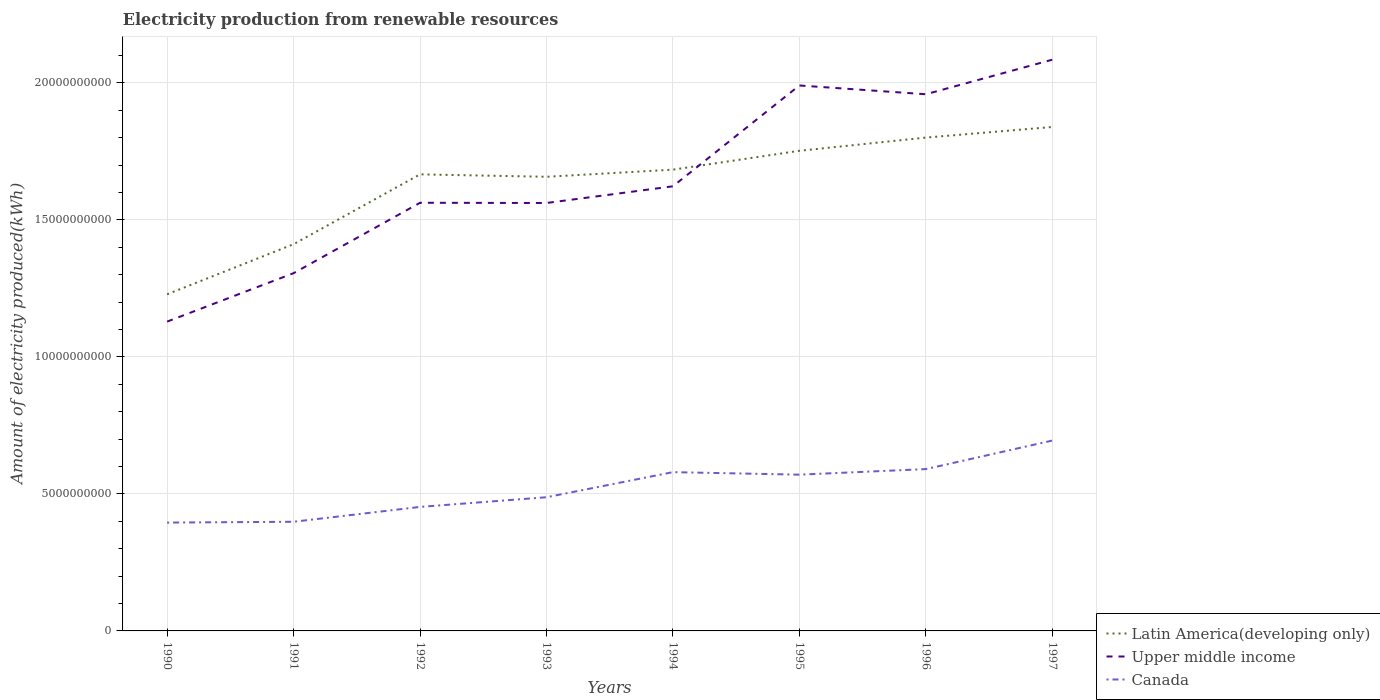How many different coloured lines are there?
Provide a succinct answer. 3. Across all years, what is the maximum amount of electricity produced in Latin America(developing only)?
Provide a succinct answer. 1.23e+1. In which year was the amount of electricity produced in Latin America(developing only) maximum?
Ensure brevity in your answer.  1990. What is the total amount of electricity produced in Latin America(developing only) in the graph?
Keep it short and to the point. -2.72e+09. What is the difference between the highest and the second highest amount of electricity produced in Canada?
Keep it short and to the point. 2.99e+09. What is the difference between the highest and the lowest amount of electricity produced in Canada?
Provide a short and direct response. 4. How many years are there in the graph?
Make the answer very short. 8. Does the graph contain any zero values?
Offer a terse response. No. Does the graph contain grids?
Offer a very short reply. Yes. Where does the legend appear in the graph?
Your response must be concise. Bottom right. How many legend labels are there?
Provide a short and direct response. 3. How are the legend labels stacked?
Your response must be concise. Vertical. What is the title of the graph?
Offer a very short reply. Electricity production from renewable resources. Does "Turkmenistan" appear as one of the legend labels in the graph?
Your answer should be very brief. No. What is the label or title of the X-axis?
Ensure brevity in your answer.  Years. What is the label or title of the Y-axis?
Your response must be concise. Amount of electricity produced(kWh). What is the Amount of electricity produced(kWh) of Latin America(developing only) in 1990?
Keep it short and to the point. 1.23e+1. What is the Amount of electricity produced(kWh) of Upper middle income in 1990?
Provide a succinct answer. 1.13e+1. What is the Amount of electricity produced(kWh) of Canada in 1990?
Provide a short and direct response. 3.95e+09. What is the Amount of electricity produced(kWh) of Latin America(developing only) in 1991?
Your response must be concise. 1.41e+1. What is the Amount of electricity produced(kWh) in Upper middle income in 1991?
Keep it short and to the point. 1.31e+1. What is the Amount of electricity produced(kWh) of Canada in 1991?
Offer a terse response. 3.98e+09. What is the Amount of electricity produced(kWh) of Latin America(developing only) in 1992?
Provide a short and direct response. 1.67e+1. What is the Amount of electricity produced(kWh) of Upper middle income in 1992?
Your answer should be compact. 1.56e+1. What is the Amount of electricity produced(kWh) in Canada in 1992?
Keep it short and to the point. 4.53e+09. What is the Amount of electricity produced(kWh) of Latin America(developing only) in 1993?
Make the answer very short. 1.66e+1. What is the Amount of electricity produced(kWh) of Upper middle income in 1993?
Give a very brief answer. 1.56e+1. What is the Amount of electricity produced(kWh) in Canada in 1993?
Provide a succinct answer. 4.88e+09. What is the Amount of electricity produced(kWh) in Latin America(developing only) in 1994?
Your answer should be compact. 1.68e+1. What is the Amount of electricity produced(kWh) in Upper middle income in 1994?
Your response must be concise. 1.62e+1. What is the Amount of electricity produced(kWh) of Canada in 1994?
Offer a very short reply. 5.80e+09. What is the Amount of electricity produced(kWh) in Latin America(developing only) in 1995?
Your response must be concise. 1.75e+1. What is the Amount of electricity produced(kWh) in Upper middle income in 1995?
Provide a short and direct response. 1.99e+1. What is the Amount of electricity produced(kWh) of Canada in 1995?
Provide a short and direct response. 5.70e+09. What is the Amount of electricity produced(kWh) of Latin America(developing only) in 1996?
Your answer should be very brief. 1.80e+1. What is the Amount of electricity produced(kWh) of Upper middle income in 1996?
Your response must be concise. 1.96e+1. What is the Amount of electricity produced(kWh) of Canada in 1996?
Your answer should be very brief. 5.91e+09. What is the Amount of electricity produced(kWh) of Latin America(developing only) in 1997?
Offer a terse response. 1.84e+1. What is the Amount of electricity produced(kWh) in Upper middle income in 1997?
Ensure brevity in your answer.  2.08e+1. What is the Amount of electricity produced(kWh) of Canada in 1997?
Offer a very short reply. 6.95e+09. Across all years, what is the maximum Amount of electricity produced(kWh) of Latin America(developing only)?
Make the answer very short. 1.84e+1. Across all years, what is the maximum Amount of electricity produced(kWh) of Upper middle income?
Your answer should be very brief. 2.08e+1. Across all years, what is the maximum Amount of electricity produced(kWh) in Canada?
Offer a terse response. 6.95e+09. Across all years, what is the minimum Amount of electricity produced(kWh) of Latin America(developing only)?
Keep it short and to the point. 1.23e+1. Across all years, what is the minimum Amount of electricity produced(kWh) in Upper middle income?
Offer a very short reply. 1.13e+1. Across all years, what is the minimum Amount of electricity produced(kWh) of Canada?
Keep it short and to the point. 3.95e+09. What is the total Amount of electricity produced(kWh) in Latin America(developing only) in the graph?
Keep it short and to the point. 1.30e+11. What is the total Amount of electricity produced(kWh) in Upper middle income in the graph?
Offer a terse response. 1.32e+11. What is the total Amount of electricity produced(kWh) of Canada in the graph?
Your answer should be compact. 4.17e+1. What is the difference between the Amount of electricity produced(kWh) in Latin America(developing only) in 1990 and that in 1991?
Ensure brevity in your answer.  -1.83e+09. What is the difference between the Amount of electricity produced(kWh) of Upper middle income in 1990 and that in 1991?
Make the answer very short. -1.77e+09. What is the difference between the Amount of electricity produced(kWh) of Canada in 1990 and that in 1991?
Offer a terse response. -3.00e+07. What is the difference between the Amount of electricity produced(kWh) in Latin America(developing only) in 1990 and that in 1992?
Keep it short and to the point. -4.38e+09. What is the difference between the Amount of electricity produced(kWh) of Upper middle income in 1990 and that in 1992?
Keep it short and to the point. -4.34e+09. What is the difference between the Amount of electricity produced(kWh) of Canada in 1990 and that in 1992?
Give a very brief answer. -5.72e+08. What is the difference between the Amount of electricity produced(kWh) in Latin America(developing only) in 1990 and that in 1993?
Ensure brevity in your answer.  -4.29e+09. What is the difference between the Amount of electricity produced(kWh) of Upper middle income in 1990 and that in 1993?
Provide a short and direct response. -4.33e+09. What is the difference between the Amount of electricity produced(kWh) of Canada in 1990 and that in 1993?
Provide a succinct answer. -9.25e+08. What is the difference between the Amount of electricity produced(kWh) of Latin America(developing only) in 1990 and that in 1994?
Offer a very short reply. -4.55e+09. What is the difference between the Amount of electricity produced(kWh) of Upper middle income in 1990 and that in 1994?
Offer a very short reply. -4.94e+09. What is the difference between the Amount of electricity produced(kWh) of Canada in 1990 and that in 1994?
Provide a succinct answer. -1.84e+09. What is the difference between the Amount of electricity produced(kWh) in Latin America(developing only) in 1990 and that in 1995?
Your response must be concise. -5.24e+09. What is the difference between the Amount of electricity produced(kWh) in Upper middle income in 1990 and that in 1995?
Make the answer very short. -8.62e+09. What is the difference between the Amount of electricity produced(kWh) of Canada in 1990 and that in 1995?
Provide a succinct answer. -1.75e+09. What is the difference between the Amount of electricity produced(kWh) of Latin America(developing only) in 1990 and that in 1996?
Provide a short and direct response. -5.72e+09. What is the difference between the Amount of electricity produced(kWh) in Upper middle income in 1990 and that in 1996?
Your answer should be very brief. -8.30e+09. What is the difference between the Amount of electricity produced(kWh) of Canada in 1990 and that in 1996?
Offer a terse response. -1.95e+09. What is the difference between the Amount of electricity produced(kWh) in Latin America(developing only) in 1990 and that in 1997?
Make the answer very short. -6.11e+09. What is the difference between the Amount of electricity produced(kWh) in Upper middle income in 1990 and that in 1997?
Provide a short and direct response. -9.56e+09. What is the difference between the Amount of electricity produced(kWh) of Canada in 1990 and that in 1997?
Keep it short and to the point. -2.99e+09. What is the difference between the Amount of electricity produced(kWh) in Latin America(developing only) in 1991 and that in 1992?
Provide a short and direct response. -2.55e+09. What is the difference between the Amount of electricity produced(kWh) of Upper middle income in 1991 and that in 1992?
Provide a short and direct response. -2.57e+09. What is the difference between the Amount of electricity produced(kWh) of Canada in 1991 and that in 1992?
Keep it short and to the point. -5.42e+08. What is the difference between the Amount of electricity produced(kWh) of Latin America(developing only) in 1991 and that in 1993?
Provide a short and direct response. -2.46e+09. What is the difference between the Amount of electricity produced(kWh) in Upper middle income in 1991 and that in 1993?
Give a very brief answer. -2.56e+09. What is the difference between the Amount of electricity produced(kWh) in Canada in 1991 and that in 1993?
Your answer should be very brief. -8.95e+08. What is the difference between the Amount of electricity produced(kWh) in Latin America(developing only) in 1991 and that in 1994?
Provide a short and direct response. -2.72e+09. What is the difference between the Amount of electricity produced(kWh) in Upper middle income in 1991 and that in 1994?
Keep it short and to the point. -3.17e+09. What is the difference between the Amount of electricity produced(kWh) of Canada in 1991 and that in 1994?
Ensure brevity in your answer.  -1.81e+09. What is the difference between the Amount of electricity produced(kWh) in Latin America(developing only) in 1991 and that in 1995?
Offer a very short reply. -3.41e+09. What is the difference between the Amount of electricity produced(kWh) in Upper middle income in 1991 and that in 1995?
Offer a very short reply. -6.85e+09. What is the difference between the Amount of electricity produced(kWh) in Canada in 1991 and that in 1995?
Ensure brevity in your answer.  -1.72e+09. What is the difference between the Amount of electricity produced(kWh) in Latin America(developing only) in 1991 and that in 1996?
Your answer should be compact. -3.89e+09. What is the difference between the Amount of electricity produced(kWh) of Upper middle income in 1991 and that in 1996?
Your answer should be very brief. -6.53e+09. What is the difference between the Amount of electricity produced(kWh) of Canada in 1991 and that in 1996?
Keep it short and to the point. -1.92e+09. What is the difference between the Amount of electricity produced(kWh) in Latin America(developing only) in 1991 and that in 1997?
Your response must be concise. -4.28e+09. What is the difference between the Amount of electricity produced(kWh) in Upper middle income in 1991 and that in 1997?
Your answer should be compact. -7.79e+09. What is the difference between the Amount of electricity produced(kWh) of Canada in 1991 and that in 1997?
Your response must be concise. -2.96e+09. What is the difference between the Amount of electricity produced(kWh) in Latin America(developing only) in 1992 and that in 1993?
Your response must be concise. 8.90e+07. What is the difference between the Amount of electricity produced(kWh) in Upper middle income in 1992 and that in 1993?
Your answer should be very brief. 8.00e+06. What is the difference between the Amount of electricity produced(kWh) in Canada in 1992 and that in 1993?
Your answer should be compact. -3.53e+08. What is the difference between the Amount of electricity produced(kWh) in Latin America(developing only) in 1992 and that in 1994?
Your answer should be compact. -1.72e+08. What is the difference between the Amount of electricity produced(kWh) in Upper middle income in 1992 and that in 1994?
Your answer should be very brief. -6.01e+08. What is the difference between the Amount of electricity produced(kWh) in Canada in 1992 and that in 1994?
Make the answer very short. -1.27e+09. What is the difference between the Amount of electricity produced(kWh) in Latin America(developing only) in 1992 and that in 1995?
Your response must be concise. -8.60e+08. What is the difference between the Amount of electricity produced(kWh) of Upper middle income in 1992 and that in 1995?
Give a very brief answer. -4.28e+09. What is the difference between the Amount of electricity produced(kWh) of Canada in 1992 and that in 1995?
Keep it short and to the point. -1.18e+09. What is the difference between the Amount of electricity produced(kWh) of Latin America(developing only) in 1992 and that in 1996?
Provide a short and direct response. -1.34e+09. What is the difference between the Amount of electricity produced(kWh) of Upper middle income in 1992 and that in 1996?
Give a very brief answer. -3.96e+09. What is the difference between the Amount of electricity produced(kWh) in Canada in 1992 and that in 1996?
Give a very brief answer. -1.38e+09. What is the difference between the Amount of electricity produced(kWh) in Latin America(developing only) in 1992 and that in 1997?
Offer a terse response. -1.73e+09. What is the difference between the Amount of electricity produced(kWh) in Upper middle income in 1992 and that in 1997?
Make the answer very short. -5.22e+09. What is the difference between the Amount of electricity produced(kWh) in Canada in 1992 and that in 1997?
Your response must be concise. -2.42e+09. What is the difference between the Amount of electricity produced(kWh) in Latin America(developing only) in 1993 and that in 1994?
Give a very brief answer. -2.61e+08. What is the difference between the Amount of electricity produced(kWh) in Upper middle income in 1993 and that in 1994?
Your answer should be compact. -6.09e+08. What is the difference between the Amount of electricity produced(kWh) of Canada in 1993 and that in 1994?
Offer a very short reply. -9.16e+08. What is the difference between the Amount of electricity produced(kWh) of Latin America(developing only) in 1993 and that in 1995?
Your response must be concise. -9.49e+08. What is the difference between the Amount of electricity produced(kWh) in Upper middle income in 1993 and that in 1995?
Give a very brief answer. -4.29e+09. What is the difference between the Amount of electricity produced(kWh) of Canada in 1993 and that in 1995?
Offer a terse response. -8.24e+08. What is the difference between the Amount of electricity produced(kWh) of Latin America(developing only) in 1993 and that in 1996?
Keep it short and to the point. -1.43e+09. What is the difference between the Amount of electricity produced(kWh) in Upper middle income in 1993 and that in 1996?
Offer a terse response. -3.97e+09. What is the difference between the Amount of electricity produced(kWh) in Canada in 1993 and that in 1996?
Offer a very short reply. -1.03e+09. What is the difference between the Amount of electricity produced(kWh) in Latin America(developing only) in 1993 and that in 1997?
Offer a terse response. -1.82e+09. What is the difference between the Amount of electricity produced(kWh) of Upper middle income in 1993 and that in 1997?
Your response must be concise. -5.23e+09. What is the difference between the Amount of electricity produced(kWh) of Canada in 1993 and that in 1997?
Your response must be concise. -2.07e+09. What is the difference between the Amount of electricity produced(kWh) in Latin America(developing only) in 1994 and that in 1995?
Provide a short and direct response. -6.88e+08. What is the difference between the Amount of electricity produced(kWh) in Upper middle income in 1994 and that in 1995?
Your response must be concise. -3.68e+09. What is the difference between the Amount of electricity produced(kWh) of Canada in 1994 and that in 1995?
Keep it short and to the point. 9.20e+07. What is the difference between the Amount of electricity produced(kWh) of Latin America(developing only) in 1994 and that in 1996?
Ensure brevity in your answer.  -1.17e+09. What is the difference between the Amount of electricity produced(kWh) of Upper middle income in 1994 and that in 1996?
Keep it short and to the point. -3.36e+09. What is the difference between the Amount of electricity produced(kWh) in Canada in 1994 and that in 1996?
Keep it short and to the point. -1.11e+08. What is the difference between the Amount of electricity produced(kWh) of Latin America(developing only) in 1994 and that in 1997?
Give a very brief answer. -1.56e+09. What is the difference between the Amount of electricity produced(kWh) of Upper middle income in 1994 and that in 1997?
Provide a short and direct response. -4.62e+09. What is the difference between the Amount of electricity produced(kWh) of Canada in 1994 and that in 1997?
Your answer should be compact. -1.15e+09. What is the difference between the Amount of electricity produced(kWh) of Latin America(developing only) in 1995 and that in 1996?
Ensure brevity in your answer.  -4.82e+08. What is the difference between the Amount of electricity produced(kWh) in Upper middle income in 1995 and that in 1996?
Make the answer very short. 3.20e+08. What is the difference between the Amount of electricity produced(kWh) in Canada in 1995 and that in 1996?
Keep it short and to the point. -2.03e+08. What is the difference between the Amount of electricity produced(kWh) in Latin America(developing only) in 1995 and that in 1997?
Keep it short and to the point. -8.69e+08. What is the difference between the Amount of electricity produced(kWh) of Upper middle income in 1995 and that in 1997?
Offer a terse response. -9.40e+08. What is the difference between the Amount of electricity produced(kWh) in Canada in 1995 and that in 1997?
Your response must be concise. -1.24e+09. What is the difference between the Amount of electricity produced(kWh) in Latin America(developing only) in 1996 and that in 1997?
Keep it short and to the point. -3.87e+08. What is the difference between the Amount of electricity produced(kWh) in Upper middle income in 1996 and that in 1997?
Offer a very short reply. -1.26e+09. What is the difference between the Amount of electricity produced(kWh) of Canada in 1996 and that in 1997?
Make the answer very short. -1.04e+09. What is the difference between the Amount of electricity produced(kWh) of Latin America(developing only) in 1990 and the Amount of electricity produced(kWh) of Upper middle income in 1991?
Your response must be concise. -7.70e+08. What is the difference between the Amount of electricity produced(kWh) in Latin America(developing only) in 1990 and the Amount of electricity produced(kWh) in Canada in 1991?
Keep it short and to the point. 8.30e+09. What is the difference between the Amount of electricity produced(kWh) in Upper middle income in 1990 and the Amount of electricity produced(kWh) in Canada in 1991?
Make the answer very short. 7.30e+09. What is the difference between the Amount of electricity produced(kWh) of Latin America(developing only) in 1990 and the Amount of electricity produced(kWh) of Upper middle income in 1992?
Provide a short and direct response. -3.34e+09. What is the difference between the Amount of electricity produced(kWh) of Latin America(developing only) in 1990 and the Amount of electricity produced(kWh) of Canada in 1992?
Make the answer very short. 7.76e+09. What is the difference between the Amount of electricity produced(kWh) in Upper middle income in 1990 and the Amount of electricity produced(kWh) in Canada in 1992?
Your answer should be compact. 6.76e+09. What is the difference between the Amount of electricity produced(kWh) in Latin America(developing only) in 1990 and the Amount of electricity produced(kWh) in Upper middle income in 1993?
Provide a succinct answer. -3.33e+09. What is the difference between the Amount of electricity produced(kWh) in Latin America(developing only) in 1990 and the Amount of electricity produced(kWh) in Canada in 1993?
Give a very brief answer. 7.41e+09. What is the difference between the Amount of electricity produced(kWh) in Upper middle income in 1990 and the Amount of electricity produced(kWh) in Canada in 1993?
Keep it short and to the point. 6.41e+09. What is the difference between the Amount of electricity produced(kWh) in Latin America(developing only) in 1990 and the Amount of electricity produced(kWh) in Upper middle income in 1994?
Your answer should be compact. -3.94e+09. What is the difference between the Amount of electricity produced(kWh) in Latin America(developing only) in 1990 and the Amount of electricity produced(kWh) in Canada in 1994?
Make the answer very short. 6.49e+09. What is the difference between the Amount of electricity produced(kWh) in Upper middle income in 1990 and the Amount of electricity produced(kWh) in Canada in 1994?
Your answer should be compact. 5.49e+09. What is the difference between the Amount of electricity produced(kWh) in Latin America(developing only) in 1990 and the Amount of electricity produced(kWh) in Upper middle income in 1995?
Offer a very short reply. -7.62e+09. What is the difference between the Amount of electricity produced(kWh) in Latin America(developing only) in 1990 and the Amount of electricity produced(kWh) in Canada in 1995?
Your response must be concise. 6.58e+09. What is the difference between the Amount of electricity produced(kWh) of Upper middle income in 1990 and the Amount of electricity produced(kWh) of Canada in 1995?
Ensure brevity in your answer.  5.59e+09. What is the difference between the Amount of electricity produced(kWh) of Latin America(developing only) in 1990 and the Amount of electricity produced(kWh) of Upper middle income in 1996?
Your answer should be very brief. -7.30e+09. What is the difference between the Amount of electricity produced(kWh) of Latin America(developing only) in 1990 and the Amount of electricity produced(kWh) of Canada in 1996?
Your answer should be compact. 6.38e+09. What is the difference between the Amount of electricity produced(kWh) in Upper middle income in 1990 and the Amount of electricity produced(kWh) in Canada in 1996?
Give a very brief answer. 5.38e+09. What is the difference between the Amount of electricity produced(kWh) in Latin America(developing only) in 1990 and the Amount of electricity produced(kWh) in Upper middle income in 1997?
Keep it short and to the point. -8.56e+09. What is the difference between the Amount of electricity produced(kWh) of Latin America(developing only) in 1990 and the Amount of electricity produced(kWh) of Canada in 1997?
Make the answer very short. 5.34e+09. What is the difference between the Amount of electricity produced(kWh) of Upper middle income in 1990 and the Amount of electricity produced(kWh) of Canada in 1997?
Your response must be concise. 4.34e+09. What is the difference between the Amount of electricity produced(kWh) in Latin America(developing only) in 1991 and the Amount of electricity produced(kWh) in Upper middle income in 1992?
Offer a terse response. -1.51e+09. What is the difference between the Amount of electricity produced(kWh) of Latin America(developing only) in 1991 and the Amount of electricity produced(kWh) of Canada in 1992?
Provide a succinct answer. 9.59e+09. What is the difference between the Amount of electricity produced(kWh) in Upper middle income in 1991 and the Amount of electricity produced(kWh) in Canada in 1992?
Your answer should be compact. 8.53e+09. What is the difference between the Amount of electricity produced(kWh) of Latin America(developing only) in 1991 and the Amount of electricity produced(kWh) of Upper middle income in 1993?
Your answer should be compact. -1.50e+09. What is the difference between the Amount of electricity produced(kWh) in Latin America(developing only) in 1991 and the Amount of electricity produced(kWh) in Canada in 1993?
Keep it short and to the point. 9.24e+09. What is the difference between the Amount of electricity produced(kWh) of Upper middle income in 1991 and the Amount of electricity produced(kWh) of Canada in 1993?
Provide a short and direct response. 8.18e+09. What is the difference between the Amount of electricity produced(kWh) in Latin America(developing only) in 1991 and the Amount of electricity produced(kWh) in Upper middle income in 1994?
Keep it short and to the point. -2.11e+09. What is the difference between the Amount of electricity produced(kWh) in Latin America(developing only) in 1991 and the Amount of electricity produced(kWh) in Canada in 1994?
Ensure brevity in your answer.  8.32e+09. What is the difference between the Amount of electricity produced(kWh) of Upper middle income in 1991 and the Amount of electricity produced(kWh) of Canada in 1994?
Your answer should be compact. 7.26e+09. What is the difference between the Amount of electricity produced(kWh) in Latin America(developing only) in 1991 and the Amount of electricity produced(kWh) in Upper middle income in 1995?
Make the answer very short. -5.79e+09. What is the difference between the Amount of electricity produced(kWh) in Latin America(developing only) in 1991 and the Amount of electricity produced(kWh) in Canada in 1995?
Give a very brief answer. 8.41e+09. What is the difference between the Amount of electricity produced(kWh) of Upper middle income in 1991 and the Amount of electricity produced(kWh) of Canada in 1995?
Your response must be concise. 7.35e+09. What is the difference between the Amount of electricity produced(kWh) of Latin America(developing only) in 1991 and the Amount of electricity produced(kWh) of Upper middle income in 1996?
Ensure brevity in your answer.  -5.47e+09. What is the difference between the Amount of electricity produced(kWh) in Latin America(developing only) in 1991 and the Amount of electricity produced(kWh) in Canada in 1996?
Offer a very short reply. 8.21e+09. What is the difference between the Amount of electricity produced(kWh) of Upper middle income in 1991 and the Amount of electricity produced(kWh) of Canada in 1996?
Give a very brief answer. 7.15e+09. What is the difference between the Amount of electricity produced(kWh) in Latin America(developing only) in 1991 and the Amount of electricity produced(kWh) in Upper middle income in 1997?
Your response must be concise. -6.73e+09. What is the difference between the Amount of electricity produced(kWh) of Latin America(developing only) in 1991 and the Amount of electricity produced(kWh) of Canada in 1997?
Your response must be concise. 7.17e+09. What is the difference between the Amount of electricity produced(kWh) of Upper middle income in 1991 and the Amount of electricity produced(kWh) of Canada in 1997?
Provide a succinct answer. 6.11e+09. What is the difference between the Amount of electricity produced(kWh) of Latin America(developing only) in 1992 and the Amount of electricity produced(kWh) of Upper middle income in 1993?
Your answer should be very brief. 1.04e+09. What is the difference between the Amount of electricity produced(kWh) of Latin America(developing only) in 1992 and the Amount of electricity produced(kWh) of Canada in 1993?
Your response must be concise. 1.18e+1. What is the difference between the Amount of electricity produced(kWh) of Upper middle income in 1992 and the Amount of electricity produced(kWh) of Canada in 1993?
Ensure brevity in your answer.  1.07e+1. What is the difference between the Amount of electricity produced(kWh) of Latin America(developing only) in 1992 and the Amount of electricity produced(kWh) of Upper middle income in 1994?
Your answer should be compact. 4.36e+08. What is the difference between the Amount of electricity produced(kWh) of Latin America(developing only) in 1992 and the Amount of electricity produced(kWh) of Canada in 1994?
Offer a very short reply. 1.09e+1. What is the difference between the Amount of electricity produced(kWh) of Upper middle income in 1992 and the Amount of electricity produced(kWh) of Canada in 1994?
Offer a terse response. 9.83e+09. What is the difference between the Amount of electricity produced(kWh) in Latin America(developing only) in 1992 and the Amount of electricity produced(kWh) in Upper middle income in 1995?
Offer a terse response. -3.24e+09. What is the difference between the Amount of electricity produced(kWh) of Latin America(developing only) in 1992 and the Amount of electricity produced(kWh) of Canada in 1995?
Provide a succinct answer. 1.10e+1. What is the difference between the Amount of electricity produced(kWh) in Upper middle income in 1992 and the Amount of electricity produced(kWh) in Canada in 1995?
Keep it short and to the point. 9.92e+09. What is the difference between the Amount of electricity produced(kWh) of Latin America(developing only) in 1992 and the Amount of electricity produced(kWh) of Upper middle income in 1996?
Offer a very short reply. -2.92e+09. What is the difference between the Amount of electricity produced(kWh) in Latin America(developing only) in 1992 and the Amount of electricity produced(kWh) in Canada in 1996?
Make the answer very short. 1.08e+1. What is the difference between the Amount of electricity produced(kWh) of Upper middle income in 1992 and the Amount of electricity produced(kWh) of Canada in 1996?
Offer a very short reply. 9.72e+09. What is the difference between the Amount of electricity produced(kWh) of Latin America(developing only) in 1992 and the Amount of electricity produced(kWh) of Upper middle income in 1997?
Make the answer very short. -4.18e+09. What is the difference between the Amount of electricity produced(kWh) of Latin America(developing only) in 1992 and the Amount of electricity produced(kWh) of Canada in 1997?
Your answer should be very brief. 9.72e+09. What is the difference between the Amount of electricity produced(kWh) of Upper middle income in 1992 and the Amount of electricity produced(kWh) of Canada in 1997?
Your response must be concise. 8.68e+09. What is the difference between the Amount of electricity produced(kWh) in Latin America(developing only) in 1993 and the Amount of electricity produced(kWh) in Upper middle income in 1994?
Make the answer very short. 3.47e+08. What is the difference between the Amount of electricity produced(kWh) in Latin America(developing only) in 1993 and the Amount of electricity produced(kWh) in Canada in 1994?
Your answer should be compact. 1.08e+1. What is the difference between the Amount of electricity produced(kWh) in Upper middle income in 1993 and the Amount of electricity produced(kWh) in Canada in 1994?
Make the answer very short. 9.82e+09. What is the difference between the Amount of electricity produced(kWh) of Latin America(developing only) in 1993 and the Amount of electricity produced(kWh) of Upper middle income in 1995?
Your response must be concise. -3.33e+09. What is the difference between the Amount of electricity produced(kWh) of Latin America(developing only) in 1993 and the Amount of electricity produced(kWh) of Canada in 1995?
Keep it short and to the point. 1.09e+1. What is the difference between the Amount of electricity produced(kWh) of Upper middle income in 1993 and the Amount of electricity produced(kWh) of Canada in 1995?
Offer a very short reply. 9.92e+09. What is the difference between the Amount of electricity produced(kWh) in Latin America(developing only) in 1993 and the Amount of electricity produced(kWh) in Upper middle income in 1996?
Offer a very short reply. -3.01e+09. What is the difference between the Amount of electricity produced(kWh) of Latin America(developing only) in 1993 and the Amount of electricity produced(kWh) of Canada in 1996?
Give a very brief answer. 1.07e+1. What is the difference between the Amount of electricity produced(kWh) in Upper middle income in 1993 and the Amount of electricity produced(kWh) in Canada in 1996?
Offer a terse response. 9.71e+09. What is the difference between the Amount of electricity produced(kWh) of Latin America(developing only) in 1993 and the Amount of electricity produced(kWh) of Upper middle income in 1997?
Keep it short and to the point. -4.27e+09. What is the difference between the Amount of electricity produced(kWh) in Latin America(developing only) in 1993 and the Amount of electricity produced(kWh) in Canada in 1997?
Provide a succinct answer. 9.63e+09. What is the difference between the Amount of electricity produced(kWh) in Upper middle income in 1993 and the Amount of electricity produced(kWh) in Canada in 1997?
Your response must be concise. 8.67e+09. What is the difference between the Amount of electricity produced(kWh) of Latin America(developing only) in 1994 and the Amount of electricity produced(kWh) of Upper middle income in 1995?
Offer a terse response. -3.07e+09. What is the difference between the Amount of electricity produced(kWh) of Latin America(developing only) in 1994 and the Amount of electricity produced(kWh) of Canada in 1995?
Provide a succinct answer. 1.11e+1. What is the difference between the Amount of electricity produced(kWh) of Upper middle income in 1994 and the Amount of electricity produced(kWh) of Canada in 1995?
Give a very brief answer. 1.05e+1. What is the difference between the Amount of electricity produced(kWh) of Latin America(developing only) in 1994 and the Amount of electricity produced(kWh) of Upper middle income in 1996?
Give a very brief answer. -2.75e+09. What is the difference between the Amount of electricity produced(kWh) of Latin America(developing only) in 1994 and the Amount of electricity produced(kWh) of Canada in 1996?
Provide a succinct answer. 1.09e+1. What is the difference between the Amount of electricity produced(kWh) of Upper middle income in 1994 and the Amount of electricity produced(kWh) of Canada in 1996?
Offer a very short reply. 1.03e+1. What is the difference between the Amount of electricity produced(kWh) of Latin America(developing only) in 1994 and the Amount of electricity produced(kWh) of Upper middle income in 1997?
Make the answer very short. -4.01e+09. What is the difference between the Amount of electricity produced(kWh) of Latin America(developing only) in 1994 and the Amount of electricity produced(kWh) of Canada in 1997?
Provide a short and direct response. 9.89e+09. What is the difference between the Amount of electricity produced(kWh) in Upper middle income in 1994 and the Amount of electricity produced(kWh) in Canada in 1997?
Ensure brevity in your answer.  9.28e+09. What is the difference between the Amount of electricity produced(kWh) of Latin America(developing only) in 1995 and the Amount of electricity produced(kWh) of Upper middle income in 1996?
Keep it short and to the point. -2.06e+09. What is the difference between the Amount of electricity produced(kWh) of Latin America(developing only) in 1995 and the Amount of electricity produced(kWh) of Canada in 1996?
Make the answer very short. 1.16e+1. What is the difference between the Amount of electricity produced(kWh) of Upper middle income in 1995 and the Amount of electricity produced(kWh) of Canada in 1996?
Your answer should be very brief. 1.40e+1. What is the difference between the Amount of electricity produced(kWh) in Latin America(developing only) in 1995 and the Amount of electricity produced(kWh) in Upper middle income in 1997?
Give a very brief answer. -3.32e+09. What is the difference between the Amount of electricity produced(kWh) in Latin America(developing only) in 1995 and the Amount of electricity produced(kWh) in Canada in 1997?
Your response must be concise. 1.06e+1. What is the difference between the Amount of electricity produced(kWh) of Upper middle income in 1995 and the Amount of electricity produced(kWh) of Canada in 1997?
Your answer should be compact. 1.30e+1. What is the difference between the Amount of electricity produced(kWh) of Latin America(developing only) in 1996 and the Amount of electricity produced(kWh) of Upper middle income in 1997?
Provide a succinct answer. -2.84e+09. What is the difference between the Amount of electricity produced(kWh) of Latin America(developing only) in 1996 and the Amount of electricity produced(kWh) of Canada in 1997?
Keep it short and to the point. 1.11e+1. What is the difference between the Amount of electricity produced(kWh) of Upper middle income in 1996 and the Amount of electricity produced(kWh) of Canada in 1997?
Your answer should be very brief. 1.26e+1. What is the average Amount of electricity produced(kWh) of Latin America(developing only) per year?
Give a very brief answer. 1.63e+1. What is the average Amount of electricity produced(kWh) of Upper middle income per year?
Your answer should be very brief. 1.65e+1. What is the average Amount of electricity produced(kWh) in Canada per year?
Provide a short and direct response. 5.21e+09. In the year 1990, what is the difference between the Amount of electricity produced(kWh) of Latin America(developing only) and Amount of electricity produced(kWh) of Upper middle income?
Your answer should be compact. 9.97e+08. In the year 1990, what is the difference between the Amount of electricity produced(kWh) of Latin America(developing only) and Amount of electricity produced(kWh) of Canada?
Offer a terse response. 8.33e+09. In the year 1990, what is the difference between the Amount of electricity produced(kWh) of Upper middle income and Amount of electricity produced(kWh) of Canada?
Ensure brevity in your answer.  7.34e+09. In the year 1991, what is the difference between the Amount of electricity produced(kWh) of Latin America(developing only) and Amount of electricity produced(kWh) of Upper middle income?
Your answer should be compact. 1.06e+09. In the year 1991, what is the difference between the Amount of electricity produced(kWh) of Latin America(developing only) and Amount of electricity produced(kWh) of Canada?
Provide a succinct answer. 1.01e+1. In the year 1991, what is the difference between the Amount of electricity produced(kWh) in Upper middle income and Amount of electricity produced(kWh) in Canada?
Ensure brevity in your answer.  9.07e+09. In the year 1992, what is the difference between the Amount of electricity produced(kWh) of Latin America(developing only) and Amount of electricity produced(kWh) of Upper middle income?
Your answer should be compact. 1.04e+09. In the year 1992, what is the difference between the Amount of electricity produced(kWh) of Latin America(developing only) and Amount of electricity produced(kWh) of Canada?
Give a very brief answer. 1.21e+1. In the year 1992, what is the difference between the Amount of electricity produced(kWh) of Upper middle income and Amount of electricity produced(kWh) of Canada?
Your answer should be compact. 1.11e+1. In the year 1993, what is the difference between the Amount of electricity produced(kWh) of Latin America(developing only) and Amount of electricity produced(kWh) of Upper middle income?
Ensure brevity in your answer.  9.56e+08. In the year 1993, what is the difference between the Amount of electricity produced(kWh) of Latin America(developing only) and Amount of electricity produced(kWh) of Canada?
Your answer should be compact. 1.17e+1. In the year 1993, what is the difference between the Amount of electricity produced(kWh) of Upper middle income and Amount of electricity produced(kWh) of Canada?
Your answer should be very brief. 1.07e+1. In the year 1994, what is the difference between the Amount of electricity produced(kWh) of Latin America(developing only) and Amount of electricity produced(kWh) of Upper middle income?
Provide a short and direct response. 6.08e+08. In the year 1994, what is the difference between the Amount of electricity produced(kWh) of Latin America(developing only) and Amount of electricity produced(kWh) of Canada?
Make the answer very short. 1.10e+1. In the year 1994, what is the difference between the Amount of electricity produced(kWh) of Upper middle income and Amount of electricity produced(kWh) of Canada?
Give a very brief answer. 1.04e+1. In the year 1995, what is the difference between the Amount of electricity produced(kWh) of Latin America(developing only) and Amount of electricity produced(kWh) of Upper middle income?
Give a very brief answer. -2.38e+09. In the year 1995, what is the difference between the Amount of electricity produced(kWh) in Latin America(developing only) and Amount of electricity produced(kWh) in Canada?
Your response must be concise. 1.18e+1. In the year 1995, what is the difference between the Amount of electricity produced(kWh) of Upper middle income and Amount of electricity produced(kWh) of Canada?
Make the answer very short. 1.42e+1. In the year 1996, what is the difference between the Amount of electricity produced(kWh) in Latin America(developing only) and Amount of electricity produced(kWh) in Upper middle income?
Keep it short and to the point. -1.58e+09. In the year 1996, what is the difference between the Amount of electricity produced(kWh) in Latin America(developing only) and Amount of electricity produced(kWh) in Canada?
Offer a very short reply. 1.21e+1. In the year 1996, what is the difference between the Amount of electricity produced(kWh) of Upper middle income and Amount of electricity produced(kWh) of Canada?
Offer a very short reply. 1.37e+1. In the year 1997, what is the difference between the Amount of electricity produced(kWh) of Latin America(developing only) and Amount of electricity produced(kWh) of Upper middle income?
Offer a very short reply. -2.46e+09. In the year 1997, what is the difference between the Amount of electricity produced(kWh) of Latin America(developing only) and Amount of electricity produced(kWh) of Canada?
Keep it short and to the point. 1.14e+1. In the year 1997, what is the difference between the Amount of electricity produced(kWh) in Upper middle income and Amount of electricity produced(kWh) in Canada?
Your answer should be compact. 1.39e+1. What is the ratio of the Amount of electricity produced(kWh) of Latin America(developing only) in 1990 to that in 1991?
Give a very brief answer. 0.87. What is the ratio of the Amount of electricity produced(kWh) of Upper middle income in 1990 to that in 1991?
Provide a succinct answer. 0.86. What is the ratio of the Amount of electricity produced(kWh) in Latin America(developing only) in 1990 to that in 1992?
Offer a terse response. 0.74. What is the ratio of the Amount of electricity produced(kWh) of Upper middle income in 1990 to that in 1992?
Offer a very short reply. 0.72. What is the ratio of the Amount of electricity produced(kWh) in Canada in 1990 to that in 1992?
Keep it short and to the point. 0.87. What is the ratio of the Amount of electricity produced(kWh) of Latin America(developing only) in 1990 to that in 1993?
Ensure brevity in your answer.  0.74. What is the ratio of the Amount of electricity produced(kWh) in Upper middle income in 1990 to that in 1993?
Your answer should be compact. 0.72. What is the ratio of the Amount of electricity produced(kWh) of Canada in 1990 to that in 1993?
Keep it short and to the point. 0.81. What is the ratio of the Amount of electricity produced(kWh) in Latin America(developing only) in 1990 to that in 1994?
Offer a terse response. 0.73. What is the ratio of the Amount of electricity produced(kWh) of Upper middle income in 1990 to that in 1994?
Make the answer very short. 0.7. What is the ratio of the Amount of electricity produced(kWh) in Canada in 1990 to that in 1994?
Give a very brief answer. 0.68. What is the ratio of the Amount of electricity produced(kWh) of Latin America(developing only) in 1990 to that in 1995?
Offer a very short reply. 0.7. What is the ratio of the Amount of electricity produced(kWh) in Upper middle income in 1990 to that in 1995?
Offer a terse response. 0.57. What is the ratio of the Amount of electricity produced(kWh) of Canada in 1990 to that in 1995?
Offer a very short reply. 0.69. What is the ratio of the Amount of electricity produced(kWh) of Latin America(developing only) in 1990 to that in 1996?
Provide a short and direct response. 0.68. What is the ratio of the Amount of electricity produced(kWh) of Upper middle income in 1990 to that in 1996?
Offer a terse response. 0.58. What is the ratio of the Amount of electricity produced(kWh) in Canada in 1990 to that in 1996?
Give a very brief answer. 0.67. What is the ratio of the Amount of electricity produced(kWh) in Latin America(developing only) in 1990 to that in 1997?
Your response must be concise. 0.67. What is the ratio of the Amount of electricity produced(kWh) in Upper middle income in 1990 to that in 1997?
Your response must be concise. 0.54. What is the ratio of the Amount of electricity produced(kWh) in Canada in 1990 to that in 1997?
Provide a succinct answer. 0.57. What is the ratio of the Amount of electricity produced(kWh) in Latin America(developing only) in 1991 to that in 1992?
Offer a terse response. 0.85. What is the ratio of the Amount of electricity produced(kWh) of Upper middle income in 1991 to that in 1992?
Offer a terse response. 0.84. What is the ratio of the Amount of electricity produced(kWh) of Canada in 1991 to that in 1992?
Your answer should be very brief. 0.88. What is the ratio of the Amount of electricity produced(kWh) of Latin America(developing only) in 1991 to that in 1993?
Offer a terse response. 0.85. What is the ratio of the Amount of electricity produced(kWh) in Upper middle income in 1991 to that in 1993?
Provide a short and direct response. 0.84. What is the ratio of the Amount of electricity produced(kWh) in Canada in 1991 to that in 1993?
Provide a succinct answer. 0.82. What is the ratio of the Amount of electricity produced(kWh) in Latin America(developing only) in 1991 to that in 1994?
Your answer should be compact. 0.84. What is the ratio of the Amount of electricity produced(kWh) of Upper middle income in 1991 to that in 1994?
Give a very brief answer. 0.8. What is the ratio of the Amount of electricity produced(kWh) in Canada in 1991 to that in 1994?
Offer a terse response. 0.69. What is the ratio of the Amount of electricity produced(kWh) in Latin America(developing only) in 1991 to that in 1995?
Your answer should be compact. 0.81. What is the ratio of the Amount of electricity produced(kWh) of Upper middle income in 1991 to that in 1995?
Your answer should be compact. 0.66. What is the ratio of the Amount of electricity produced(kWh) in Canada in 1991 to that in 1995?
Give a very brief answer. 0.7. What is the ratio of the Amount of electricity produced(kWh) of Latin America(developing only) in 1991 to that in 1996?
Ensure brevity in your answer.  0.78. What is the ratio of the Amount of electricity produced(kWh) of Upper middle income in 1991 to that in 1996?
Provide a succinct answer. 0.67. What is the ratio of the Amount of electricity produced(kWh) in Canada in 1991 to that in 1996?
Provide a succinct answer. 0.67. What is the ratio of the Amount of electricity produced(kWh) of Latin America(developing only) in 1991 to that in 1997?
Keep it short and to the point. 0.77. What is the ratio of the Amount of electricity produced(kWh) in Upper middle income in 1991 to that in 1997?
Provide a short and direct response. 0.63. What is the ratio of the Amount of electricity produced(kWh) in Canada in 1991 to that in 1997?
Give a very brief answer. 0.57. What is the ratio of the Amount of electricity produced(kWh) of Latin America(developing only) in 1992 to that in 1993?
Your answer should be compact. 1.01. What is the ratio of the Amount of electricity produced(kWh) in Upper middle income in 1992 to that in 1993?
Give a very brief answer. 1. What is the ratio of the Amount of electricity produced(kWh) of Canada in 1992 to that in 1993?
Offer a terse response. 0.93. What is the ratio of the Amount of electricity produced(kWh) of Latin America(developing only) in 1992 to that in 1994?
Offer a terse response. 0.99. What is the ratio of the Amount of electricity produced(kWh) in Canada in 1992 to that in 1994?
Provide a short and direct response. 0.78. What is the ratio of the Amount of electricity produced(kWh) of Latin America(developing only) in 1992 to that in 1995?
Keep it short and to the point. 0.95. What is the ratio of the Amount of electricity produced(kWh) in Upper middle income in 1992 to that in 1995?
Your answer should be very brief. 0.79. What is the ratio of the Amount of electricity produced(kWh) in Canada in 1992 to that in 1995?
Offer a very short reply. 0.79. What is the ratio of the Amount of electricity produced(kWh) in Latin America(developing only) in 1992 to that in 1996?
Your answer should be compact. 0.93. What is the ratio of the Amount of electricity produced(kWh) in Upper middle income in 1992 to that in 1996?
Provide a succinct answer. 0.8. What is the ratio of the Amount of electricity produced(kWh) of Canada in 1992 to that in 1996?
Ensure brevity in your answer.  0.77. What is the ratio of the Amount of electricity produced(kWh) of Latin America(developing only) in 1992 to that in 1997?
Your answer should be very brief. 0.91. What is the ratio of the Amount of electricity produced(kWh) of Upper middle income in 1992 to that in 1997?
Your answer should be compact. 0.75. What is the ratio of the Amount of electricity produced(kWh) of Canada in 1992 to that in 1997?
Provide a succinct answer. 0.65. What is the ratio of the Amount of electricity produced(kWh) in Latin America(developing only) in 1993 to that in 1994?
Make the answer very short. 0.98. What is the ratio of the Amount of electricity produced(kWh) in Upper middle income in 1993 to that in 1994?
Your answer should be very brief. 0.96. What is the ratio of the Amount of electricity produced(kWh) in Canada in 1993 to that in 1994?
Offer a very short reply. 0.84. What is the ratio of the Amount of electricity produced(kWh) of Latin America(developing only) in 1993 to that in 1995?
Keep it short and to the point. 0.95. What is the ratio of the Amount of electricity produced(kWh) in Upper middle income in 1993 to that in 1995?
Your answer should be compact. 0.78. What is the ratio of the Amount of electricity produced(kWh) of Canada in 1993 to that in 1995?
Offer a terse response. 0.86. What is the ratio of the Amount of electricity produced(kWh) of Latin America(developing only) in 1993 to that in 1996?
Provide a succinct answer. 0.92. What is the ratio of the Amount of electricity produced(kWh) of Upper middle income in 1993 to that in 1996?
Offer a very short reply. 0.8. What is the ratio of the Amount of electricity produced(kWh) in Canada in 1993 to that in 1996?
Your answer should be very brief. 0.83. What is the ratio of the Amount of electricity produced(kWh) in Latin America(developing only) in 1993 to that in 1997?
Ensure brevity in your answer.  0.9. What is the ratio of the Amount of electricity produced(kWh) of Upper middle income in 1993 to that in 1997?
Provide a short and direct response. 0.75. What is the ratio of the Amount of electricity produced(kWh) of Canada in 1993 to that in 1997?
Provide a short and direct response. 0.7. What is the ratio of the Amount of electricity produced(kWh) in Latin America(developing only) in 1994 to that in 1995?
Ensure brevity in your answer.  0.96. What is the ratio of the Amount of electricity produced(kWh) in Upper middle income in 1994 to that in 1995?
Your response must be concise. 0.82. What is the ratio of the Amount of electricity produced(kWh) of Canada in 1994 to that in 1995?
Your response must be concise. 1.02. What is the ratio of the Amount of electricity produced(kWh) in Latin America(developing only) in 1994 to that in 1996?
Ensure brevity in your answer.  0.94. What is the ratio of the Amount of electricity produced(kWh) in Upper middle income in 1994 to that in 1996?
Offer a terse response. 0.83. What is the ratio of the Amount of electricity produced(kWh) of Canada in 1994 to that in 1996?
Ensure brevity in your answer.  0.98. What is the ratio of the Amount of electricity produced(kWh) in Latin America(developing only) in 1994 to that in 1997?
Provide a short and direct response. 0.92. What is the ratio of the Amount of electricity produced(kWh) in Upper middle income in 1994 to that in 1997?
Offer a terse response. 0.78. What is the ratio of the Amount of electricity produced(kWh) of Canada in 1994 to that in 1997?
Offer a terse response. 0.83. What is the ratio of the Amount of electricity produced(kWh) of Latin America(developing only) in 1995 to that in 1996?
Make the answer very short. 0.97. What is the ratio of the Amount of electricity produced(kWh) in Upper middle income in 1995 to that in 1996?
Your response must be concise. 1.02. What is the ratio of the Amount of electricity produced(kWh) in Canada in 1995 to that in 1996?
Keep it short and to the point. 0.97. What is the ratio of the Amount of electricity produced(kWh) of Latin America(developing only) in 1995 to that in 1997?
Your response must be concise. 0.95. What is the ratio of the Amount of electricity produced(kWh) in Upper middle income in 1995 to that in 1997?
Provide a short and direct response. 0.95. What is the ratio of the Amount of electricity produced(kWh) of Canada in 1995 to that in 1997?
Keep it short and to the point. 0.82. What is the ratio of the Amount of electricity produced(kWh) of Upper middle income in 1996 to that in 1997?
Offer a terse response. 0.94. What is the ratio of the Amount of electricity produced(kWh) of Canada in 1996 to that in 1997?
Give a very brief answer. 0.85. What is the difference between the highest and the second highest Amount of electricity produced(kWh) of Latin America(developing only)?
Provide a short and direct response. 3.87e+08. What is the difference between the highest and the second highest Amount of electricity produced(kWh) of Upper middle income?
Give a very brief answer. 9.40e+08. What is the difference between the highest and the second highest Amount of electricity produced(kWh) in Canada?
Keep it short and to the point. 1.04e+09. What is the difference between the highest and the lowest Amount of electricity produced(kWh) of Latin America(developing only)?
Give a very brief answer. 6.11e+09. What is the difference between the highest and the lowest Amount of electricity produced(kWh) of Upper middle income?
Keep it short and to the point. 9.56e+09. What is the difference between the highest and the lowest Amount of electricity produced(kWh) in Canada?
Your response must be concise. 2.99e+09. 